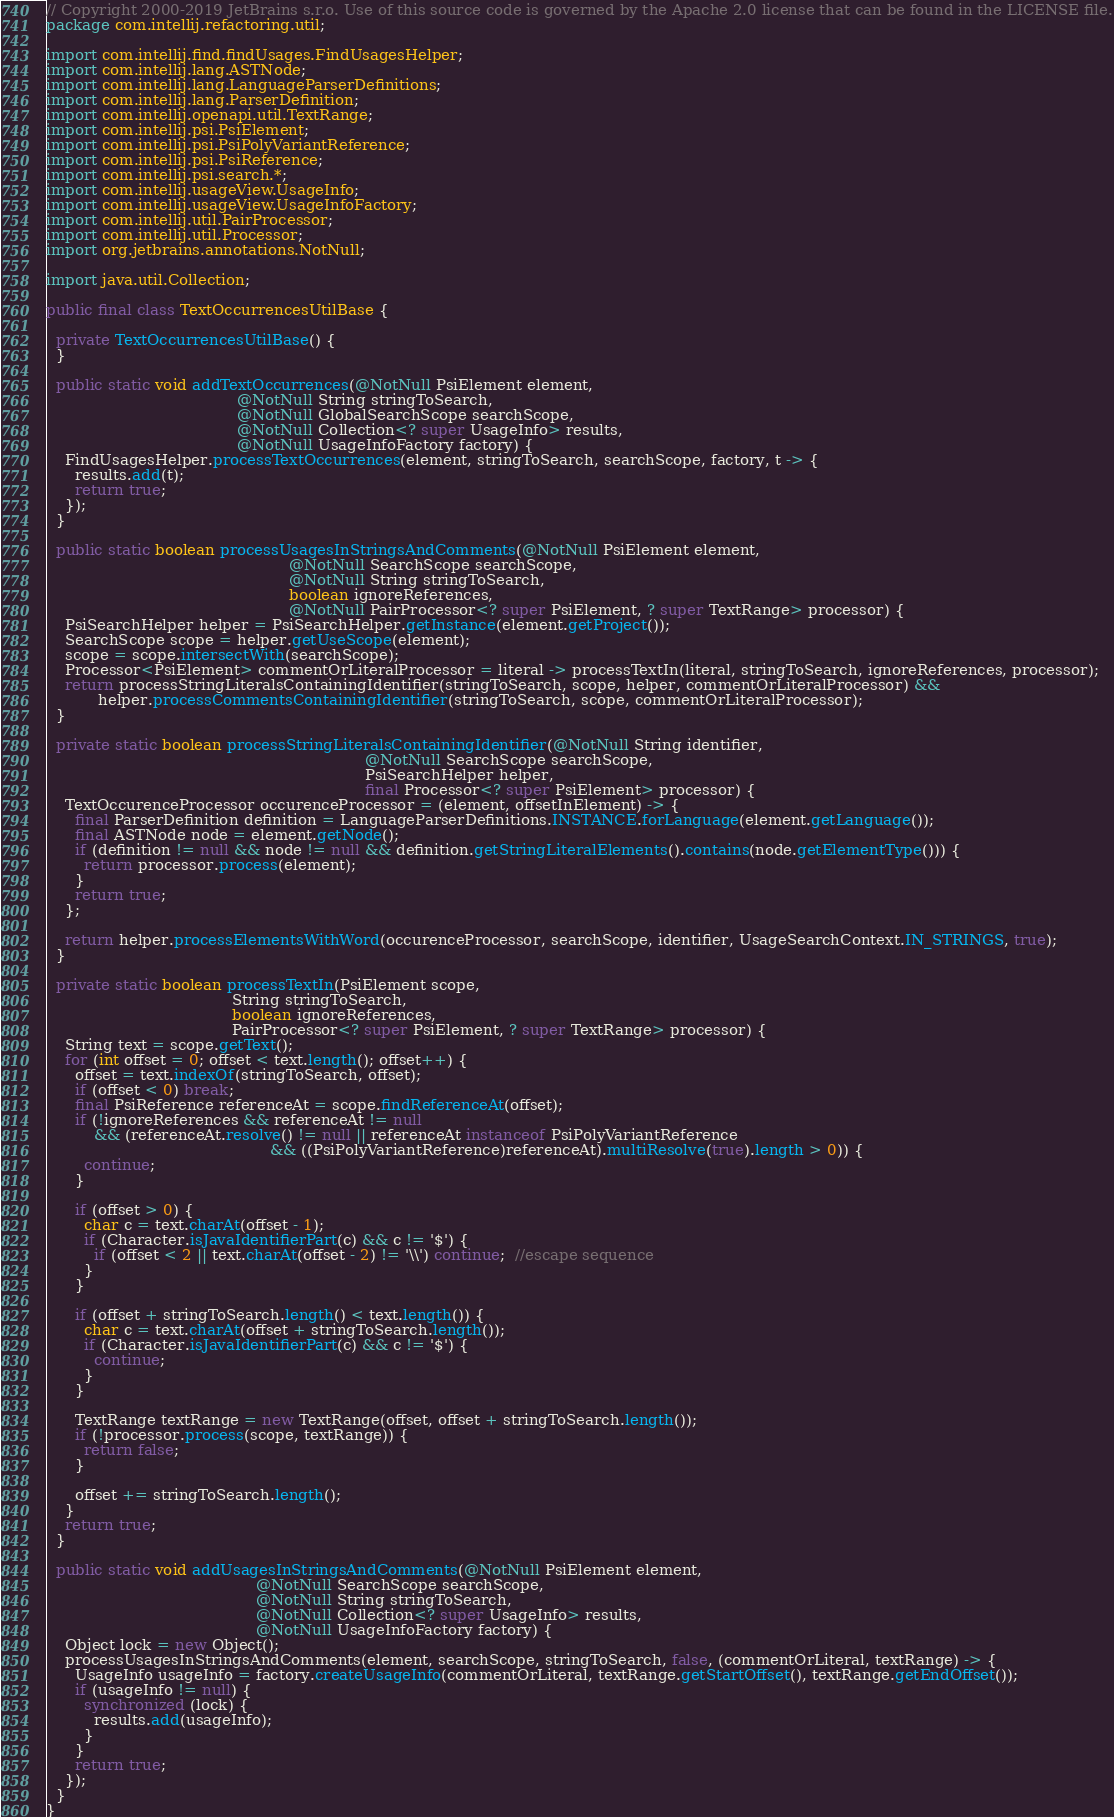Convert code to text. <code><loc_0><loc_0><loc_500><loc_500><_Java_>// Copyright 2000-2019 JetBrains s.r.o. Use of this source code is governed by the Apache 2.0 license that can be found in the LICENSE file.
package com.intellij.refactoring.util;

import com.intellij.find.findUsages.FindUsagesHelper;
import com.intellij.lang.ASTNode;
import com.intellij.lang.LanguageParserDefinitions;
import com.intellij.lang.ParserDefinition;
import com.intellij.openapi.util.TextRange;
import com.intellij.psi.PsiElement;
import com.intellij.psi.PsiPolyVariantReference;
import com.intellij.psi.PsiReference;
import com.intellij.psi.search.*;
import com.intellij.usageView.UsageInfo;
import com.intellij.usageView.UsageInfoFactory;
import com.intellij.util.PairProcessor;
import com.intellij.util.Processor;
import org.jetbrains.annotations.NotNull;

import java.util.Collection;

public final class TextOccurrencesUtilBase {

  private TextOccurrencesUtilBase() {
  }

  public static void addTextOccurrences(@NotNull PsiElement element,
                                        @NotNull String stringToSearch,
                                        @NotNull GlobalSearchScope searchScope,
                                        @NotNull Collection<? super UsageInfo> results,
                                        @NotNull UsageInfoFactory factory) {
    FindUsagesHelper.processTextOccurrences(element, stringToSearch, searchScope, factory, t -> {
      results.add(t);
      return true;
    });
  }

  public static boolean processUsagesInStringsAndComments(@NotNull PsiElement element,
                                                   @NotNull SearchScope searchScope,
                                                   @NotNull String stringToSearch,
                                                   boolean ignoreReferences,
                                                   @NotNull PairProcessor<? super PsiElement, ? super TextRange> processor) {
    PsiSearchHelper helper = PsiSearchHelper.getInstance(element.getProject());
    SearchScope scope = helper.getUseScope(element);
    scope = scope.intersectWith(searchScope);
    Processor<PsiElement> commentOrLiteralProcessor = literal -> processTextIn(literal, stringToSearch, ignoreReferences, processor);
    return processStringLiteralsContainingIdentifier(stringToSearch, scope, helper, commentOrLiteralProcessor) &&
           helper.processCommentsContainingIdentifier(stringToSearch, scope, commentOrLiteralProcessor);
  }

  private static boolean processStringLiteralsContainingIdentifier(@NotNull String identifier,
                                                                   @NotNull SearchScope searchScope,
                                                                   PsiSearchHelper helper,
                                                                   final Processor<? super PsiElement> processor) {
    TextOccurenceProcessor occurenceProcessor = (element, offsetInElement) -> {
      final ParserDefinition definition = LanguageParserDefinitions.INSTANCE.forLanguage(element.getLanguage());
      final ASTNode node = element.getNode();
      if (definition != null && node != null && definition.getStringLiteralElements().contains(node.getElementType())) {
        return processor.process(element);
      }
      return true;
    };

    return helper.processElementsWithWord(occurenceProcessor, searchScope, identifier, UsageSearchContext.IN_STRINGS, true);
  }

  private static boolean processTextIn(PsiElement scope,
                                       String stringToSearch,
                                       boolean ignoreReferences,
                                       PairProcessor<? super PsiElement, ? super TextRange> processor) {
    String text = scope.getText();
    for (int offset = 0; offset < text.length(); offset++) {
      offset = text.indexOf(stringToSearch, offset);
      if (offset < 0) break;
      final PsiReference referenceAt = scope.findReferenceAt(offset);
      if (!ignoreReferences && referenceAt != null
          && (referenceAt.resolve() != null || referenceAt instanceof PsiPolyVariantReference
                                               && ((PsiPolyVariantReference)referenceAt).multiResolve(true).length > 0)) {
        continue;
      }

      if (offset > 0) {
        char c = text.charAt(offset - 1);
        if (Character.isJavaIdentifierPart(c) && c != '$') {
          if (offset < 2 || text.charAt(offset - 2) != '\\') continue;  //escape sequence
        }
      }

      if (offset + stringToSearch.length() < text.length()) {
        char c = text.charAt(offset + stringToSearch.length());
        if (Character.isJavaIdentifierPart(c) && c != '$') {
          continue;
        }
      }

      TextRange textRange = new TextRange(offset, offset + stringToSearch.length());
      if (!processor.process(scope, textRange)) {
        return false;
      }

      offset += stringToSearch.length();
    }
    return true;
  }

  public static void addUsagesInStringsAndComments(@NotNull PsiElement element,
                                            @NotNull SearchScope searchScope,
                                            @NotNull String stringToSearch,
                                            @NotNull Collection<? super UsageInfo> results,
                                            @NotNull UsageInfoFactory factory) {
    Object lock = new Object();
    processUsagesInStringsAndComments(element, searchScope, stringToSearch, false, (commentOrLiteral, textRange) -> {
      UsageInfo usageInfo = factory.createUsageInfo(commentOrLiteral, textRange.getStartOffset(), textRange.getEndOffset());
      if (usageInfo != null) {
        synchronized (lock) {
          results.add(usageInfo);
        }
      }
      return true;
    });
  }
}
</code> 